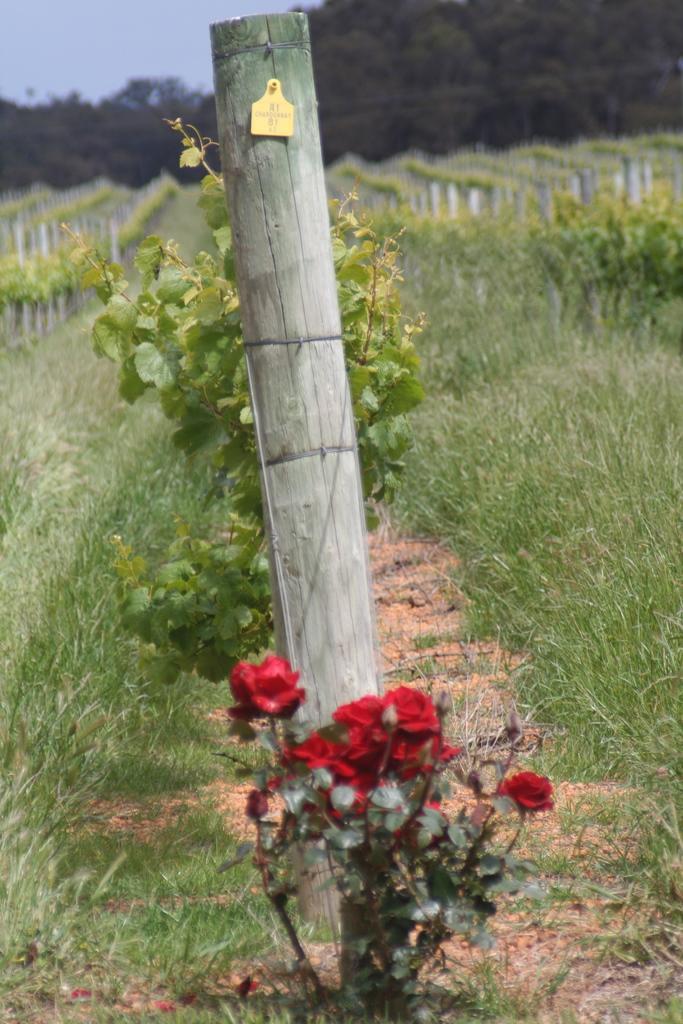Please provide a concise description of this image. In this image we can see a flower plant. There are plants and grass. There is a sticker on the wooden object. In the background we can see trees and sky.   